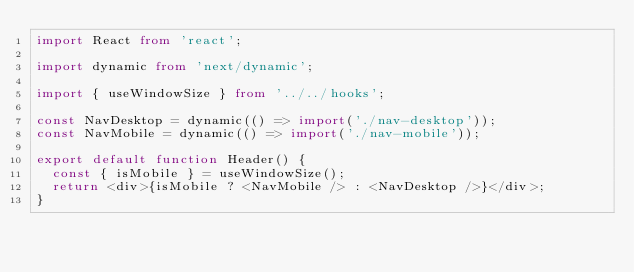Convert code to text. <code><loc_0><loc_0><loc_500><loc_500><_TypeScript_>import React from 'react';

import dynamic from 'next/dynamic';

import { useWindowSize } from '../../hooks';

const NavDesktop = dynamic(() => import('./nav-desktop'));
const NavMobile = dynamic(() => import('./nav-mobile'));

export default function Header() {
  const { isMobile } = useWindowSize();
  return <div>{isMobile ? <NavMobile /> : <NavDesktop />}</div>;
}
</code> 